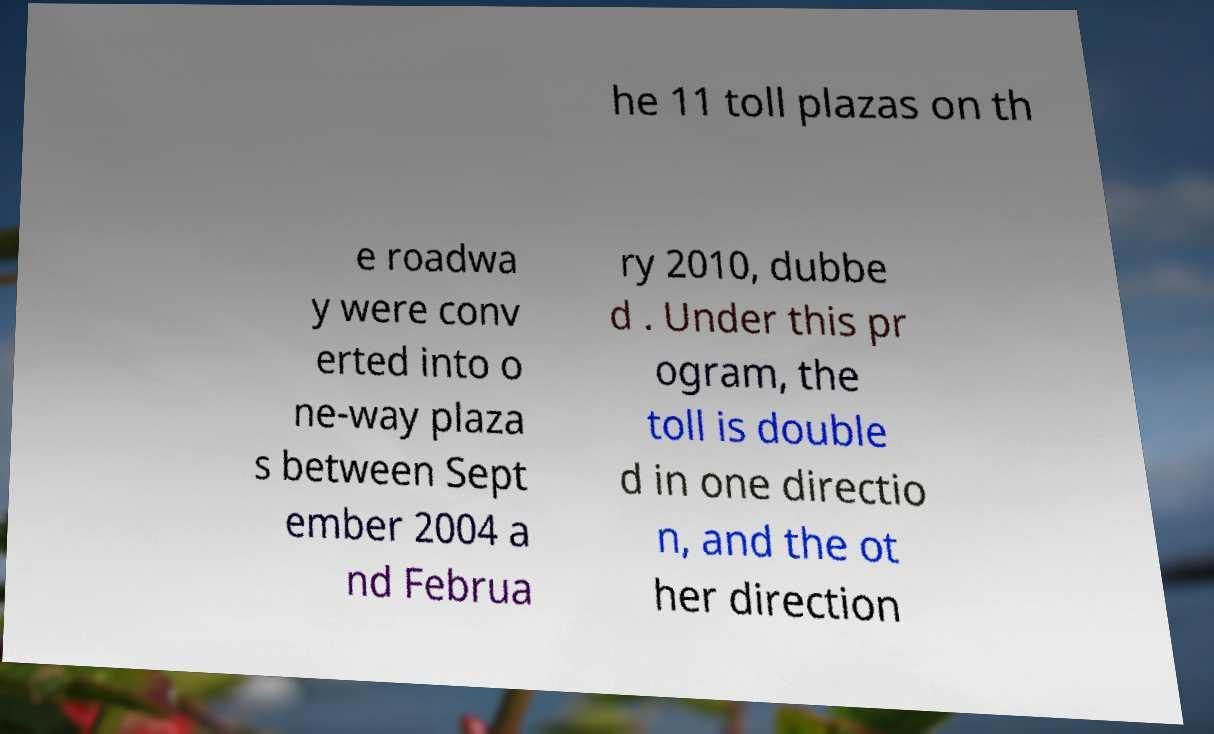Please read and relay the text visible in this image. What does it say? he 11 toll plazas on th e roadwa y were conv erted into o ne-way plaza s between Sept ember 2004 a nd Februa ry 2010, dubbe d . Under this pr ogram, the toll is double d in one directio n, and the ot her direction 